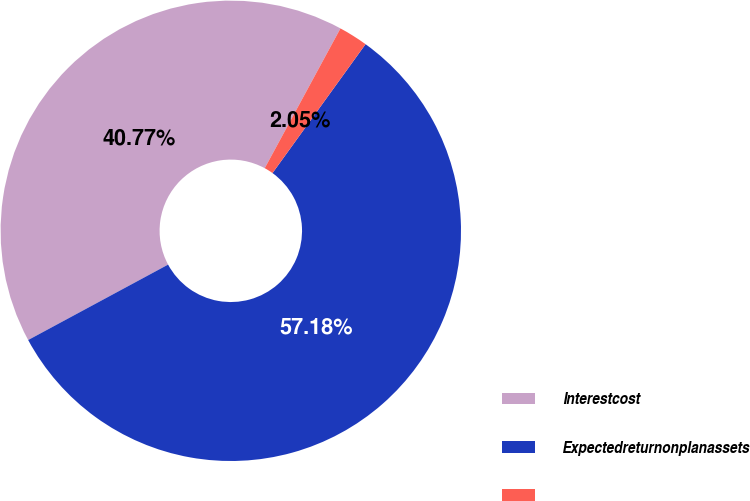Convert chart. <chart><loc_0><loc_0><loc_500><loc_500><pie_chart><fcel>Interestcost<fcel>Expectedreturnonplanassets<fcel>Unnamed: 2<nl><fcel>40.77%<fcel>57.18%<fcel>2.05%<nl></chart> 